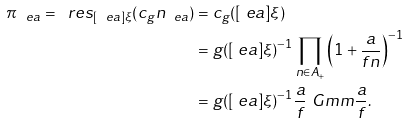<formula> <loc_0><loc_0><loc_500><loc_500>\pi _ { \ e a } = \ r e s _ { [ \ e a ] \xi } ( c _ { g } n _ { \ e a } ) & = c _ { g } ( [ \ e a ] \xi ) \\ & = g ( [ \ e a ] \xi ) ^ { - 1 } \prod _ { n \in A _ { + } } \left ( 1 + \frac { a } { f n } \right ) ^ { - 1 } \\ & = g ( [ \ e a ] \xi ) ^ { - 1 } \frac { a } { f } \ G m m { \frac { a } { f } } .</formula> 